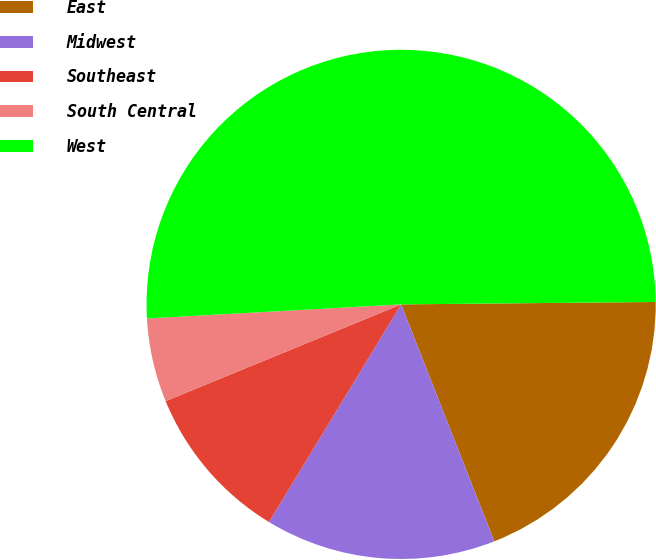Convert chart. <chart><loc_0><loc_0><loc_500><loc_500><pie_chart><fcel>East<fcel>Midwest<fcel>Southeast<fcel>South Central<fcel>West<nl><fcel>19.19%<fcel>14.65%<fcel>10.11%<fcel>5.32%<fcel>50.73%<nl></chart> 